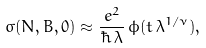<formula> <loc_0><loc_0><loc_500><loc_500>\sigma ( N , B , 0 ) \approx \frac { \, e ^ { 2 } } { \hbar { \, } \lambda } \, \phi ( t \, \lambda ^ { 1 / \nu } ) ,</formula> 